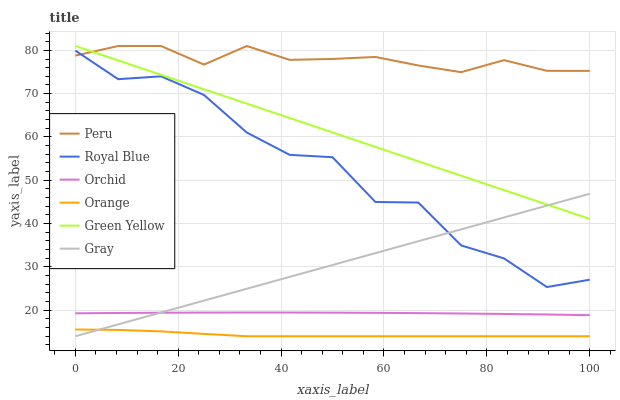Does Orange have the minimum area under the curve?
Answer yes or no. Yes. Does Peru have the maximum area under the curve?
Answer yes or no. Yes. Does Royal Blue have the minimum area under the curve?
Answer yes or no. No. Does Royal Blue have the maximum area under the curve?
Answer yes or no. No. Is Gray the smoothest?
Answer yes or no. Yes. Is Royal Blue the roughest?
Answer yes or no. Yes. Is Peru the smoothest?
Answer yes or no. No. Is Peru the roughest?
Answer yes or no. No. Does Gray have the lowest value?
Answer yes or no. Yes. Does Royal Blue have the lowest value?
Answer yes or no. No. Does Green Yellow have the highest value?
Answer yes or no. Yes. Does Royal Blue have the highest value?
Answer yes or no. No. Is Orange less than Peru?
Answer yes or no. Yes. Is Royal Blue greater than Orchid?
Answer yes or no. Yes. Does Peru intersect Green Yellow?
Answer yes or no. Yes. Is Peru less than Green Yellow?
Answer yes or no. No. Is Peru greater than Green Yellow?
Answer yes or no. No. Does Orange intersect Peru?
Answer yes or no. No. 